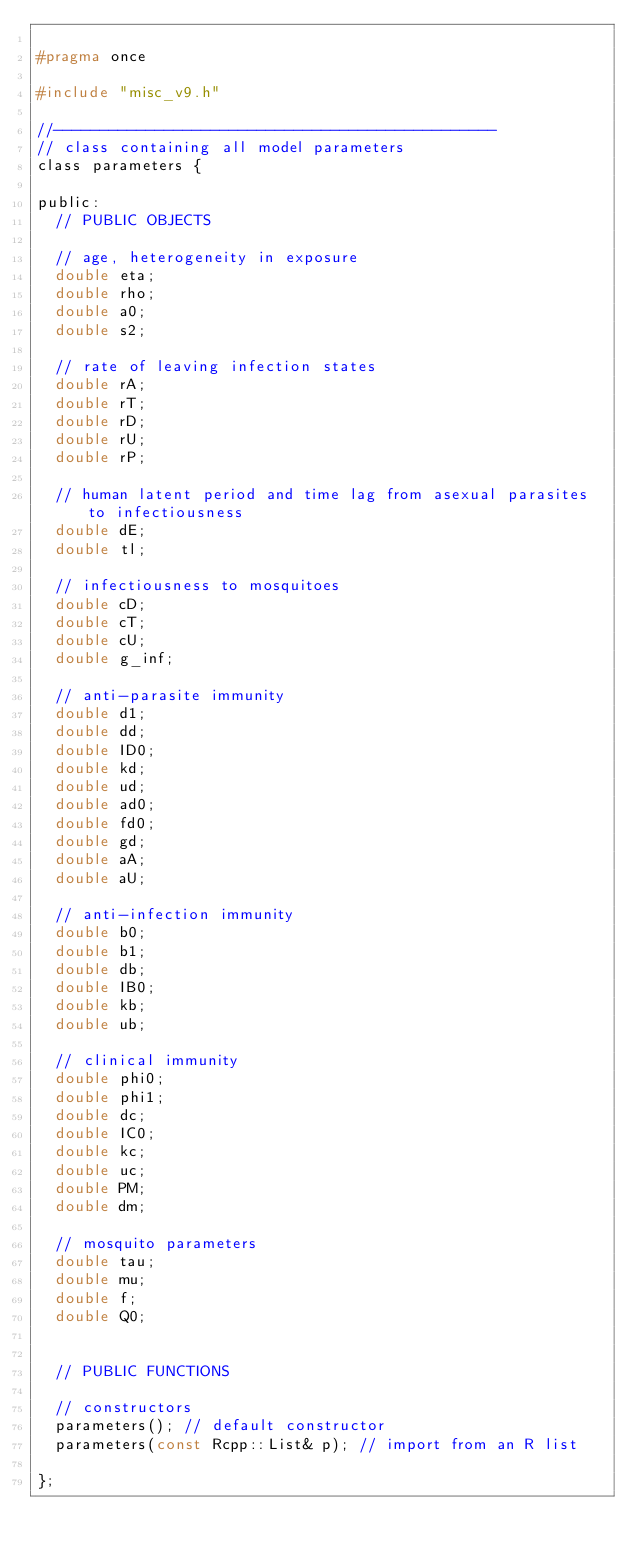Convert code to text. <code><loc_0><loc_0><loc_500><loc_500><_C_>
#pragma once

#include "misc_v9.h"

//------------------------------------------------
// class containing all model parameters
class parameters {
  
public:
  // PUBLIC OBJECTS
  
  // age, heterogeneity in exposure
  double eta;
  double rho;
  double a0;
  double s2;
  
  // rate of leaving infection states
  double rA;
  double rT;
  double rD;
  double rU;
  double rP;
  
  // human latent period and time lag from asexual parasites to infectiousness
  double dE;
  double tl;
  
  // infectiousness to mosquitoes
  double cD;
  double cT;
  double cU;
  double g_inf;
  
  // anti-parasite immunity
  double d1;
  double dd;
  double ID0;
  double kd;
  double ud;
  double ad0;
  double fd0;
  double gd;
  double aA;
  double aU;
  
  // anti-infection immunity
  double b0;
  double b1;
  double db;
  double IB0;
  double kb;
  double ub;
  
  // clinical immunity
  double phi0;
  double phi1;
  double dc;
  double IC0;
  double kc;
  double uc;
  double PM;
  double dm;
  
  // mosquito parameters
  double tau;
  double mu;
  double f;
  double Q0;
  
  
  // PUBLIC FUNCTIONS
  
  // constructors
  parameters(); // default constructor
  parameters(const Rcpp::List& p); // import from an R list
  
};

</code> 